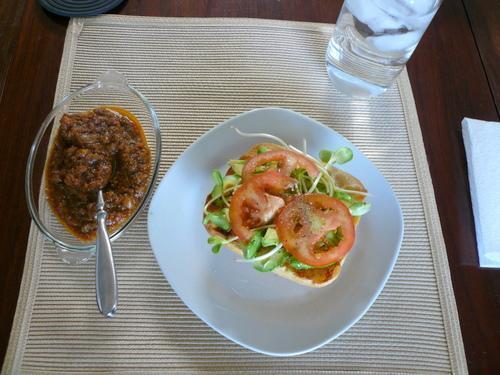How many glasses are in the picture?
Give a very brief answer. 1. How many plates are there?
Give a very brief answer. 1. How many people will be eating?
Give a very brief answer. 1. How many plates of food?
Give a very brief answer. 1. How many bowls can be seen?
Give a very brief answer. 2. 